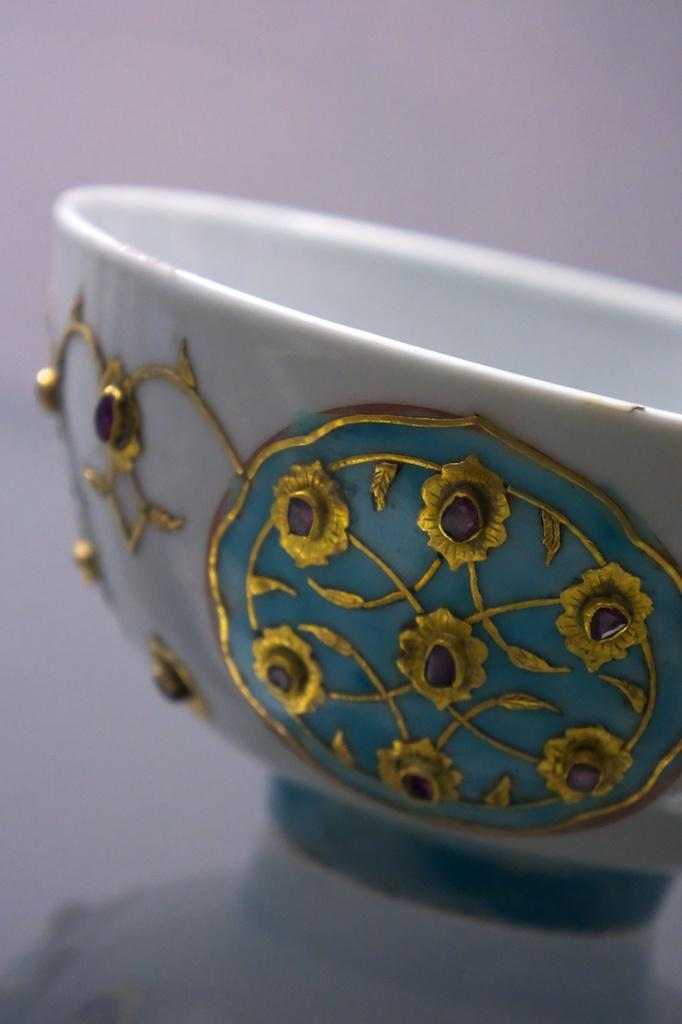What is in the image that is used for holding items? There is a bowl in the image that is used for holding items. What color is the bowl in the image? The bowl is white in color. What decorative elements are on the bowl? There are flowers on the bowl. What is the color of the flowers on the bowl? The flowers on the bowl are golden in color. Where is the bowl located in the image? The bowl is placed on a table. What type of crowd can be seen gathering around the bowl in the image? There is no crowd present in the image; it only features a bowl with golden flowers on a table. 